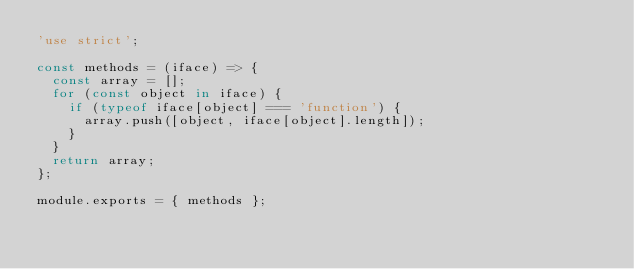Convert code to text. <code><loc_0><loc_0><loc_500><loc_500><_JavaScript_>'use strict';

const methods = (iface) => {
  const array = [];
  for (const object in iface) {
    if (typeof iface[object] === 'function') {
      array.push([object, iface[object].length]);
    }
  }
  return array;
};

module.exports = { methods };
</code> 